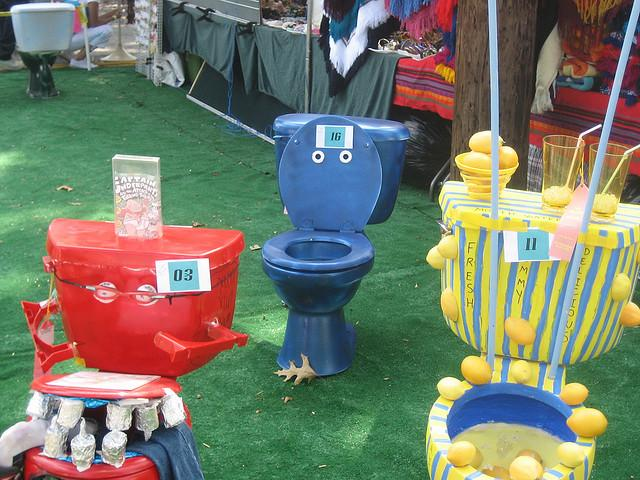The artistically displayed items here are normally connected to what? plumbing 